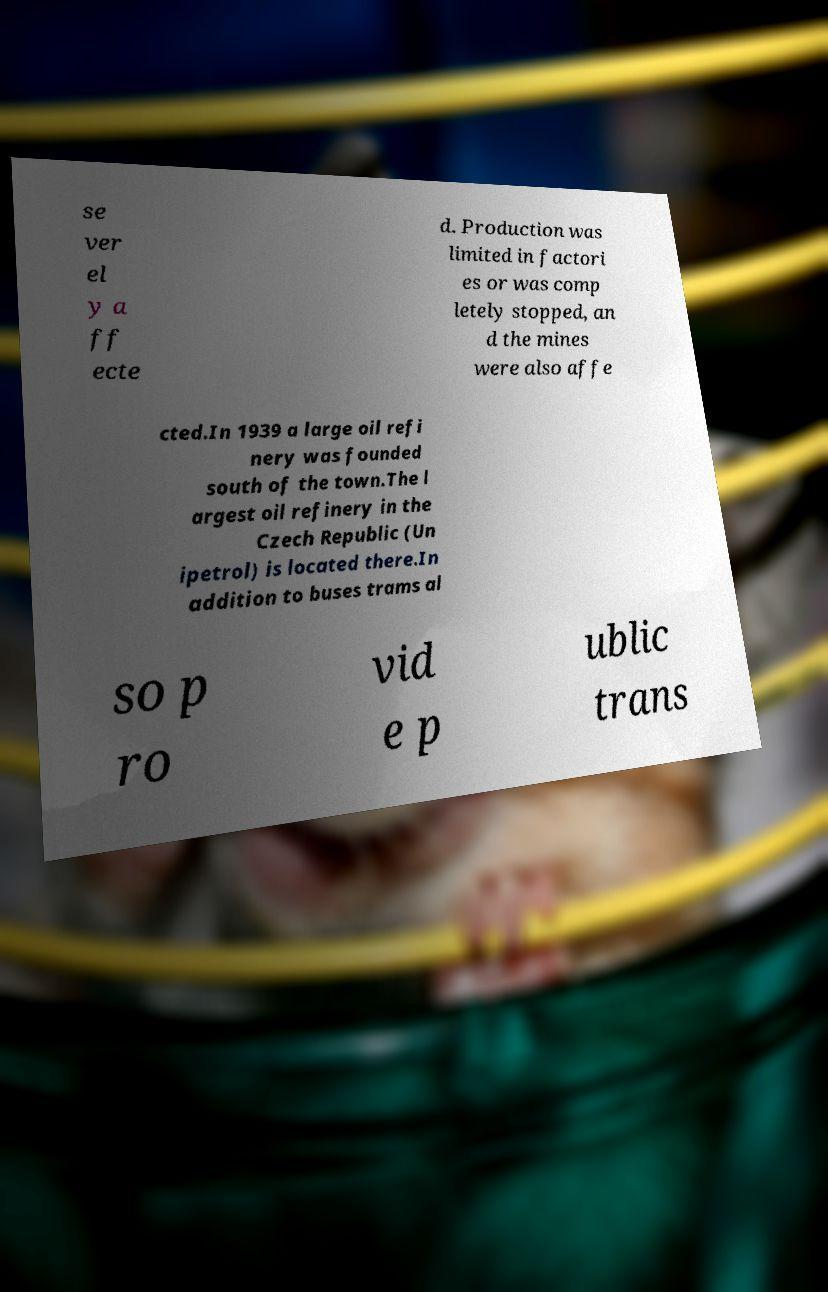Please read and relay the text visible in this image. What does it say? se ver el y a ff ecte d. Production was limited in factori es or was comp letely stopped, an d the mines were also affe cted.In 1939 a large oil refi nery was founded south of the town.The l argest oil refinery in the Czech Republic (Un ipetrol) is located there.In addition to buses trams al so p ro vid e p ublic trans 